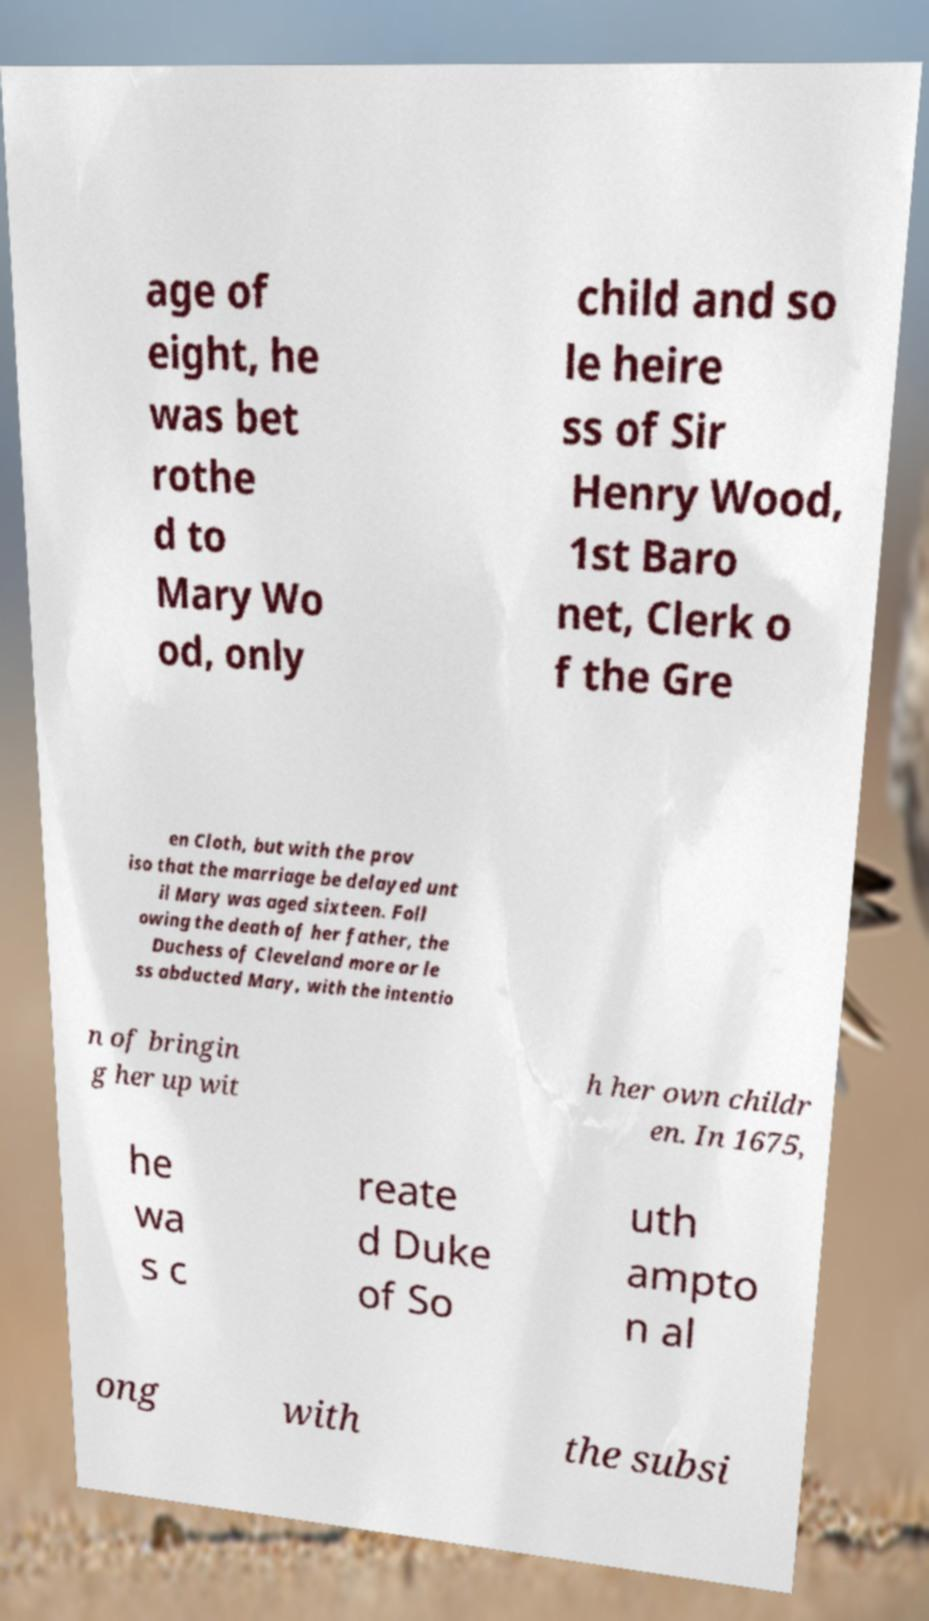Can you accurately transcribe the text from the provided image for me? age of eight, he was bet rothe d to Mary Wo od, only child and so le heire ss of Sir Henry Wood, 1st Baro net, Clerk o f the Gre en Cloth, but with the prov iso that the marriage be delayed unt il Mary was aged sixteen. Foll owing the death of her father, the Duchess of Cleveland more or le ss abducted Mary, with the intentio n of bringin g her up wit h her own childr en. In 1675, he wa s c reate d Duke of So uth ampto n al ong with the subsi 